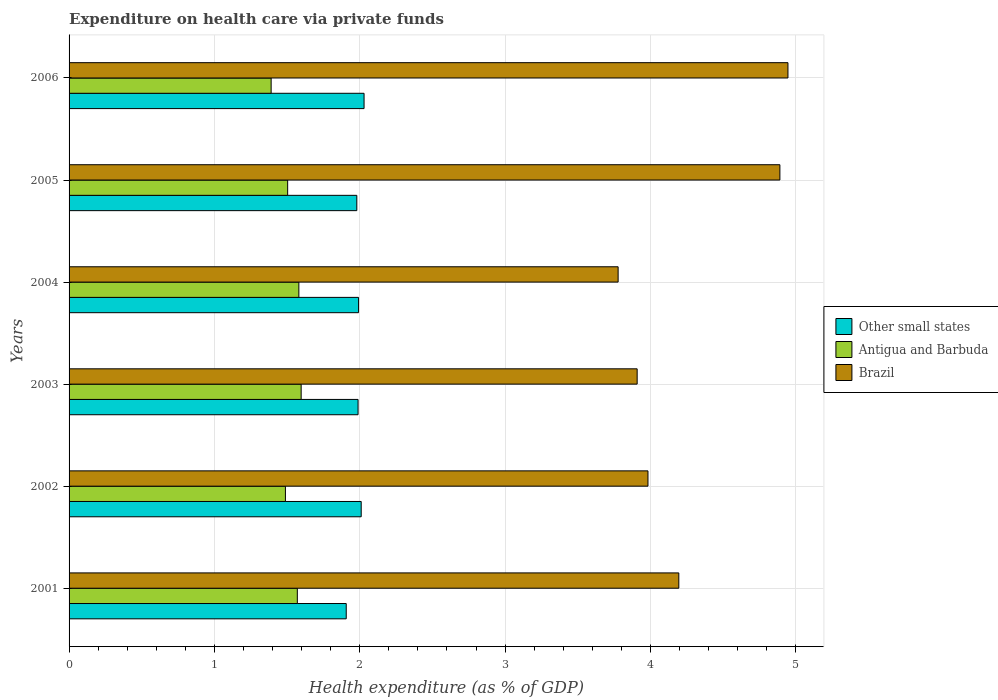How many different coloured bars are there?
Provide a succinct answer. 3. Are the number of bars per tick equal to the number of legend labels?
Keep it short and to the point. Yes. Are the number of bars on each tick of the Y-axis equal?
Offer a very short reply. Yes. How many bars are there on the 1st tick from the top?
Offer a terse response. 3. In how many cases, is the number of bars for a given year not equal to the number of legend labels?
Ensure brevity in your answer.  0. What is the expenditure made on health care in Brazil in 2003?
Ensure brevity in your answer.  3.91. Across all years, what is the maximum expenditure made on health care in Antigua and Barbuda?
Keep it short and to the point. 1.6. Across all years, what is the minimum expenditure made on health care in Antigua and Barbuda?
Ensure brevity in your answer.  1.39. What is the total expenditure made on health care in Antigua and Barbuda in the graph?
Your response must be concise. 9.13. What is the difference between the expenditure made on health care in Antigua and Barbuda in 2002 and that in 2005?
Give a very brief answer. -0.02. What is the difference between the expenditure made on health care in Other small states in 2004 and the expenditure made on health care in Antigua and Barbuda in 2003?
Give a very brief answer. 0.4. What is the average expenditure made on health care in Antigua and Barbuda per year?
Offer a very short reply. 1.52. In the year 2002, what is the difference between the expenditure made on health care in Antigua and Barbuda and expenditure made on health care in Brazil?
Your response must be concise. -2.49. What is the ratio of the expenditure made on health care in Other small states in 2001 to that in 2005?
Ensure brevity in your answer.  0.96. Is the expenditure made on health care in Brazil in 2003 less than that in 2005?
Your response must be concise. Yes. Is the difference between the expenditure made on health care in Antigua and Barbuda in 2003 and 2004 greater than the difference between the expenditure made on health care in Brazil in 2003 and 2004?
Keep it short and to the point. No. What is the difference between the highest and the second highest expenditure made on health care in Brazil?
Provide a succinct answer. 0.06. What is the difference between the highest and the lowest expenditure made on health care in Other small states?
Ensure brevity in your answer.  0.12. In how many years, is the expenditure made on health care in Brazil greater than the average expenditure made on health care in Brazil taken over all years?
Make the answer very short. 2. What does the 2nd bar from the top in 2005 represents?
Give a very brief answer. Antigua and Barbuda. How many bars are there?
Your response must be concise. 18. How many years are there in the graph?
Give a very brief answer. 6. Are the values on the major ticks of X-axis written in scientific E-notation?
Ensure brevity in your answer.  No. Does the graph contain any zero values?
Make the answer very short. No. Does the graph contain grids?
Ensure brevity in your answer.  Yes. How many legend labels are there?
Your response must be concise. 3. How are the legend labels stacked?
Offer a terse response. Vertical. What is the title of the graph?
Offer a very short reply. Expenditure on health care via private funds. Does "Sri Lanka" appear as one of the legend labels in the graph?
Your answer should be very brief. No. What is the label or title of the X-axis?
Provide a succinct answer. Health expenditure (as % of GDP). What is the Health expenditure (as % of GDP) of Other small states in 2001?
Provide a short and direct response. 1.91. What is the Health expenditure (as % of GDP) of Antigua and Barbuda in 2001?
Provide a short and direct response. 1.57. What is the Health expenditure (as % of GDP) in Brazil in 2001?
Offer a very short reply. 4.19. What is the Health expenditure (as % of GDP) of Other small states in 2002?
Your response must be concise. 2.01. What is the Health expenditure (as % of GDP) of Antigua and Barbuda in 2002?
Provide a succinct answer. 1.49. What is the Health expenditure (as % of GDP) of Brazil in 2002?
Your response must be concise. 3.98. What is the Health expenditure (as % of GDP) of Other small states in 2003?
Provide a short and direct response. 1.99. What is the Health expenditure (as % of GDP) in Antigua and Barbuda in 2003?
Your answer should be compact. 1.6. What is the Health expenditure (as % of GDP) of Brazil in 2003?
Give a very brief answer. 3.91. What is the Health expenditure (as % of GDP) of Other small states in 2004?
Offer a very short reply. 1.99. What is the Health expenditure (as % of GDP) of Antigua and Barbuda in 2004?
Offer a terse response. 1.58. What is the Health expenditure (as % of GDP) of Brazil in 2004?
Give a very brief answer. 3.78. What is the Health expenditure (as % of GDP) of Other small states in 2005?
Offer a very short reply. 1.98. What is the Health expenditure (as % of GDP) of Antigua and Barbuda in 2005?
Offer a terse response. 1.5. What is the Health expenditure (as % of GDP) of Brazil in 2005?
Your answer should be very brief. 4.89. What is the Health expenditure (as % of GDP) of Other small states in 2006?
Offer a terse response. 2.03. What is the Health expenditure (as % of GDP) of Antigua and Barbuda in 2006?
Make the answer very short. 1.39. What is the Health expenditure (as % of GDP) in Brazil in 2006?
Give a very brief answer. 4.95. Across all years, what is the maximum Health expenditure (as % of GDP) in Other small states?
Offer a terse response. 2.03. Across all years, what is the maximum Health expenditure (as % of GDP) of Antigua and Barbuda?
Offer a terse response. 1.6. Across all years, what is the maximum Health expenditure (as % of GDP) of Brazil?
Offer a terse response. 4.95. Across all years, what is the minimum Health expenditure (as % of GDP) in Other small states?
Your answer should be compact. 1.91. Across all years, what is the minimum Health expenditure (as % of GDP) of Antigua and Barbuda?
Your response must be concise. 1.39. Across all years, what is the minimum Health expenditure (as % of GDP) of Brazil?
Provide a succinct answer. 3.78. What is the total Health expenditure (as % of GDP) in Other small states in the graph?
Offer a terse response. 11.91. What is the total Health expenditure (as % of GDP) in Antigua and Barbuda in the graph?
Provide a succinct answer. 9.13. What is the total Health expenditure (as % of GDP) of Brazil in the graph?
Ensure brevity in your answer.  25.7. What is the difference between the Health expenditure (as % of GDP) of Other small states in 2001 and that in 2002?
Give a very brief answer. -0.1. What is the difference between the Health expenditure (as % of GDP) in Antigua and Barbuda in 2001 and that in 2002?
Offer a very short reply. 0.08. What is the difference between the Health expenditure (as % of GDP) of Brazil in 2001 and that in 2002?
Your answer should be compact. 0.21. What is the difference between the Health expenditure (as % of GDP) of Other small states in 2001 and that in 2003?
Your answer should be compact. -0.08. What is the difference between the Health expenditure (as % of GDP) in Antigua and Barbuda in 2001 and that in 2003?
Offer a terse response. -0.03. What is the difference between the Health expenditure (as % of GDP) of Brazil in 2001 and that in 2003?
Keep it short and to the point. 0.29. What is the difference between the Health expenditure (as % of GDP) in Other small states in 2001 and that in 2004?
Keep it short and to the point. -0.08. What is the difference between the Health expenditure (as % of GDP) in Antigua and Barbuda in 2001 and that in 2004?
Offer a terse response. -0.01. What is the difference between the Health expenditure (as % of GDP) of Brazil in 2001 and that in 2004?
Provide a short and direct response. 0.42. What is the difference between the Health expenditure (as % of GDP) of Other small states in 2001 and that in 2005?
Your answer should be very brief. -0.07. What is the difference between the Health expenditure (as % of GDP) of Antigua and Barbuda in 2001 and that in 2005?
Give a very brief answer. 0.07. What is the difference between the Health expenditure (as % of GDP) of Brazil in 2001 and that in 2005?
Provide a succinct answer. -0.7. What is the difference between the Health expenditure (as % of GDP) of Other small states in 2001 and that in 2006?
Your answer should be compact. -0.12. What is the difference between the Health expenditure (as % of GDP) in Antigua and Barbuda in 2001 and that in 2006?
Make the answer very short. 0.18. What is the difference between the Health expenditure (as % of GDP) of Brazil in 2001 and that in 2006?
Provide a short and direct response. -0.75. What is the difference between the Health expenditure (as % of GDP) in Other small states in 2002 and that in 2003?
Give a very brief answer. 0.02. What is the difference between the Health expenditure (as % of GDP) of Antigua and Barbuda in 2002 and that in 2003?
Your answer should be very brief. -0.11. What is the difference between the Health expenditure (as % of GDP) in Brazil in 2002 and that in 2003?
Provide a short and direct response. 0.07. What is the difference between the Health expenditure (as % of GDP) in Other small states in 2002 and that in 2004?
Give a very brief answer. 0.02. What is the difference between the Health expenditure (as % of GDP) in Antigua and Barbuda in 2002 and that in 2004?
Keep it short and to the point. -0.09. What is the difference between the Health expenditure (as % of GDP) in Brazil in 2002 and that in 2004?
Provide a succinct answer. 0.21. What is the difference between the Health expenditure (as % of GDP) in Other small states in 2002 and that in 2005?
Your answer should be very brief. 0.03. What is the difference between the Health expenditure (as % of GDP) of Antigua and Barbuda in 2002 and that in 2005?
Give a very brief answer. -0.02. What is the difference between the Health expenditure (as % of GDP) of Brazil in 2002 and that in 2005?
Your answer should be very brief. -0.91. What is the difference between the Health expenditure (as % of GDP) in Other small states in 2002 and that in 2006?
Make the answer very short. -0.02. What is the difference between the Health expenditure (as % of GDP) in Antigua and Barbuda in 2002 and that in 2006?
Offer a very short reply. 0.1. What is the difference between the Health expenditure (as % of GDP) of Brazil in 2002 and that in 2006?
Make the answer very short. -0.96. What is the difference between the Health expenditure (as % of GDP) of Other small states in 2003 and that in 2004?
Keep it short and to the point. -0. What is the difference between the Health expenditure (as % of GDP) of Antigua and Barbuda in 2003 and that in 2004?
Offer a very short reply. 0.02. What is the difference between the Health expenditure (as % of GDP) in Brazil in 2003 and that in 2004?
Provide a succinct answer. 0.13. What is the difference between the Health expenditure (as % of GDP) in Other small states in 2003 and that in 2005?
Keep it short and to the point. 0.01. What is the difference between the Health expenditure (as % of GDP) in Antigua and Barbuda in 2003 and that in 2005?
Give a very brief answer. 0.09. What is the difference between the Health expenditure (as % of GDP) of Brazil in 2003 and that in 2005?
Give a very brief answer. -0.98. What is the difference between the Health expenditure (as % of GDP) in Other small states in 2003 and that in 2006?
Offer a very short reply. -0.04. What is the difference between the Health expenditure (as % of GDP) in Antigua and Barbuda in 2003 and that in 2006?
Your answer should be very brief. 0.21. What is the difference between the Health expenditure (as % of GDP) in Brazil in 2003 and that in 2006?
Your response must be concise. -1.04. What is the difference between the Health expenditure (as % of GDP) in Other small states in 2004 and that in 2005?
Your answer should be compact. 0.01. What is the difference between the Health expenditure (as % of GDP) of Antigua and Barbuda in 2004 and that in 2005?
Keep it short and to the point. 0.08. What is the difference between the Health expenditure (as % of GDP) in Brazil in 2004 and that in 2005?
Offer a terse response. -1.11. What is the difference between the Health expenditure (as % of GDP) in Other small states in 2004 and that in 2006?
Provide a short and direct response. -0.04. What is the difference between the Health expenditure (as % of GDP) in Antigua and Barbuda in 2004 and that in 2006?
Offer a terse response. 0.19. What is the difference between the Health expenditure (as % of GDP) in Brazil in 2004 and that in 2006?
Give a very brief answer. -1.17. What is the difference between the Health expenditure (as % of GDP) of Other small states in 2005 and that in 2006?
Your answer should be compact. -0.05. What is the difference between the Health expenditure (as % of GDP) in Antigua and Barbuda in 2005 and that in 2006?
Offer a terse response. 0.11. What is the difference between the Health expenditure (as % of GDP) of Brazil in 2005 and that in 2006?
Provide a short and direct response. -0.06. What is the difference between the Health expenditure (as % of GDP) of Other small states in 2001 and the Health expenditure (as % of GDP) of Antigua and Barbuda in 2002?
Your response must be concise. 0.42. What is the difference between the Health expenditure (as % of GDP) in Other small states in 2001 and the Health expenditure (as % of GDP) in Brazil in 2002?
Make the answer very short. -2.08. What is the difference between the Health expenditure (as % of GDP) of Antigua and Barbuda in 2001 and the Health expenditure (as % of GDP) of Brazil in 2002?
Ensure brevity in your answer.  -2.41. What is the difference between the Health expenditure (as % of GDP) in Other small states in 2001 and the Health expenditure (as % of GDP) in Antigua and Barbuda in 2003?
Keep it short and to the point. 0.31. What is the difference between the Health expenditure (as % of GDP) of Other small states in 2001 and the Health expenditure (as % of GDP) of Brazil in 2003?
Offer a very short reply. -2. What is the difference between the Health expenditure (as % of GDP) in Antigua and Barbuda in 2001 and the Health expenditure (as % of GDP) in Brazil in 2003?
Your answer should be very brief. -2.34. What is the difference between the Health expenditure (as % of GDP) in Other small states in 2001 and the Health expenditure (as % of GDP) in Antigua and Barbuda in 2004?
Keep it short and to the point. 0.33. What is the difference between the Health expenditure (as % of GDP) in Other small states in 2001 and the Health expenditure (as % of GDP) in Brazil in 2004?
Your response must be concise. -1.87. What is the difference between the Health expenditure (as % of GDP) in Antigua and Barbuda in 2001 and the Health expenditure (as % of GDP) in Brazil in 2004?
Provide a succinct answer. -2.21. What is the difference between the Health expenditure (as % of GDP) of Other small states in 2001 and the Health expenditure (as % of GDP) of Antigua and Barbuda in 2005?
Make the answer very short. 0.4. What is the difference between the Health expenditure (as % of GDP) of Other small states in 2001 and the Health expenditure (as % of GDP) of Brazil in 2005?
Your answer should be compact. -2.98. What is the difference between the Health expenditure (as % of GDP) in Antigua and Barbuda in 2001 and the Health expenditure (as % of GDP) in Brazil in 2005?
Your response must be concise. -3.32. What is the difference between the Health expenditure (as % of GDP) of Other small states in 2001 and the Health expenditure (as % of GDP) of Antigua and Barbuda in 2006?
Provide a short and direct response. 0.52. What is the difference between the Health expenditure (as % of GDP) of Other small states in 2001 and the Health expenditure (as % of GDP) of Brazil in 2006?
Ensure brevity in your answer.  -3.04. What is the difference between the Health expenditure (as % of GDP) of Antigua and Barbuda in 2001 and the Health expenditure (as % of GDP) of Brazil in 2006?
Provide a short and direct response. -3.38. What is the difference between the Health expenditure (as % of GDP) of Other small states in 2002 and the Health expenditure (as % of GDP) of Antigua and Barbuda in 2003?
Offer a terse response. 0.41. What is the difference between the Health expenditure (as % of GDP) in Other small states in 2002 and the Health expenditure (as % of GDP) in Brazil in 2003?
Your answer should be compact. -1.9. What is the difference between the Health expenditure (as % of GDP) of Antigua and Barbuda in 2002 and the Health expenditure (as % of GDP) of Brazil in 2003?
Ensure brevity in your answer.  -2.42. What is the difference between the Health expenditure (as % of GDP) of Other small states in 2002 and the Health expenditure (as % of GDP) of Antigua and Barbuda in 2004?
Offer a terse response. 0.43. What is the difference between the Health expenditure (as % of GDP) in Other small states in 2002 and the Health expenditure (as % of GDP) in Brazil in 2004?
Give a very brief answer. -1.77. What is the difference between the Health expenditure (as % of GDP) in Antigua and Barbuda in 2002 and the Health expenditure (as % of GDP) in Brazil in 2004?
Your answer should be very brief. -2.29. What is the difference between the Health expenditure (as % of GDP) in Other small states in 2002 and the Health expenditure (as % of GDP) in Antigua and Barbuda in 2005?
Offer a terse response. 0.51. What is the difference between the Health expenditure (as % of GDP) in Other small states in 2002 and the Health expenditure (as % of GDP) in Brazil in 2005?
Your answer should be very brief. -2.88. What is the difference between the Health expenditure (as % of GDP) of Antigua and Barbuda in 2002 and the Health expenditure (as % of GDP) of Brazil in 2005?
Offer a very short reply. -3.4. What is the difference between the Health expenditure (as % of GDP) of Other small states in 2002 and the Health expenditure (as % of GDP) of Antigua and Barbuda in 2006?
Give a very brief answer. 0.62. What is the difference between the Health expenditure (as % of GDP) in Other small states in 2002 and the Health expenditure (as % of GDP) in Brazil in 2006?
Your answer should be very brief. -2.94. What is the difference between the Health expenditure (as % of GDP) in Antigua and Barbuda in 2002 and the Health expenditure (as % of GDP) in Brazil in 2006?
Make the answer very short. -3.46. What is the difference between the Health expenditure (as % of GDP) in Other small states in 2003 and the Health expenditure (as % of GDP) in Antigua and Barbuda in 2004?
Ensure brevity in your answer.  0.41. What is the difference between the Health expenditure (as % of GDP) in Other small states in 2003 and the Health expenditure (as % of GDP) in Brazil in 2004?
Provide a short and direct response. -1.79. What is the difference between the Health expenditure (as % of GDP) in Antigua and Barbuda in 2003 and the Health expenditure (as % of GDP) in Brazil in 2004?
Provide a succinct answer. -2.18. What is the difference between the Health expenditure (as % of GDP) of Other small states in 2003 and the Health expenditure (as % of GDP) of Antigua and Barbuda in 2005?
Offer a terse response. 0.48. What is the difference between the Health expenditure (as % of GDP) in Other small states in 2003 and the Health expenditure (as % of GDP) in Brazil in 2005?
Your response must be concise. -2.9. What is the difference between the Health expenditure (as % of GDP) of Antigua and Barbuda in 2003 and the Health expenditure (as % of GDP) of Brazil in 2005?
Your response must be concise. -3.29. What is the difference between the Health expenditure (as % of GDP) in Other small states in 2003 and the Health expenditure (as % of GDP) in Antigua and Barbuda in 2006?
Offer a very short reply. 0.6. What is the difference between the Health expenditure (as % of GDP) in Other small states in 2003 and the Health expenditure (as % of GDP) in Brazil in 2006?
Provide a short and direct response. -2.96. What is the difference between the Health expenditure (as % of GDP) in Antigua and Barbuda in 2003 and the Health expenditure (as % of GDP) in Brazil in 2006?
Your answer should be very brief. -3.35. What is the difference between the Health expenditure (as % of GDP) in Other small states in 2004 and the Health expenditure (as % of GDP) in Antigua and Barbuda in 2005?
Make the answer very short. 0.49. What is the difference between the Health expenditure (as % of GDP) in Other small states in 2004 and the Health expenditure (as % of GDP) in Brazil in 2005?
Ensure brevity in your answer.  -2.9. What is the difference between the Health expenditure (as % of GDP) of Antigua and Barbuda in 2004 and the Health expenditure (as % of GDP) of Brazil in 2005?
Provide a short and direct response. -3.31. What is the difference between the Health expenditure (as % of GDP) in Other small states in 2004 and the Health expenditure (as % of GDP) in Antigua and Barbuda in 2006?
Ensure brevity in your answer.  0.6. What is the difference between the Health expenditure (as % of GDP) of Other small states in 2004 and the Health expenditure (as % of GDP) of Brazil in 2006?
Your answer should be very brief. -2.95. What is the difference between the Health expenditure (as % of GDP) in Antigua and Barbuda in 2004 and the Health expenditure (as % of GDP) in Brazil in 2006?
Offer a terse response. -3.36. What is the difference between the Health expenditure (as % of GDP) in Other small states in 2005 and the Health expenditure (as % of GDP) in Antigua and Barbuda in 2006?
Provide a succinct answer. 0.59. What is the difference between the Health expenditure (as % of GDP) in Other small states in 2005 and the Health expenditure (as % of GDP) in Brazil in 2006?
Provide a short and direct response. -2.97. What is the difference between the Health expenditure (as % of GDP) of Antigua and Barbuda in 2005 and the Health expenditure (as % of GDP) of Brazil in 2006?
Provide a short and direct response. -3.44. What is the average Health expenditure (as % of GDP) in Other small states per year?
Offer a terse response. 1.98. What is the average Health expenditure (as % of GDP) in Antigua and Barbuda per year?
Ensure brevity in your answer.  1.52. What is the average Health expenditure (as % of GDP) of Brazil per year?
Keep it short and to the point. 4.28. In the year 2001, what is the difference between the Health expenditure (as % of GDP) in Other small states and Health expenditure (as % of GDP) in Antigua and Barbuda?
Your response must be concise. 0.34. In the year 2001, what is the difference between the Health expenditure (as % of GDP) in Other small states and Health expenditure (as % of GDP) in Brazil?
Offer a very short reply. -2.29. In the year 2001, what is the difference between the Health expenditure (as % of GDP) in Antigua and Barbuda and Health expenditure (as % of GDP) in Brazil?
Provide a short and direct response. -2.62. In the year 2002, what is the difference between the Health expenditure (as % of GDP) of Other small states and Health expenditure (as % of GDP) of Antigua and Barbuda?
Your response must be concise. 0.52. In the year 2002, what is the difference between the Health expenditure (as % of GDP) in Other small states and Health expenditure (as % of GDP) in Brazil?
Ensure brevity in your answer.  -1.97. In the year 2002, what is the difference between the Health expenditure (as % of GDP) in Antigua and Barbuda and Health expenditure (as % of GDP) in Brazil?
Offer a very short reply. -2.49. In the year 2003, what is the difference between the Health expenditure (as % of GDP) of Other small states and Health expenditure (as % of GDP) of Antigua and Barbuda?
Offer a very short reply. 0.39. In the year 2003, what is the difference between the Health expenditure (as % of GDP) of Other small states and Health expenditure (as % of GDP) of Brazil?
Your answer should be compact. -1.92. In the year 2003, what is the difference between the Health expenditure (as % of GDP) of Antigua and Barbuda and Health expenditure (as % of GDP) of Brazil?
Your answer should be very brief. -2.31. In the year 2004, what is the difference between the Health expenditure (as % of GDP) in Other small states and Health expenditure (as % of GDP) in Antigua and Barbuda?
Provide a succinct answer. 0.41. In the year 2004, what is the difference between the Health expenditure (as % of GDP) in Other small states and Health expenditure (as % of GDP) in Brazil?
Offer a very short reply. -1.79. In the year 2004, what is the difference between the Health expenditure (as % of GDP) in Antigua and Barbuda and Health expenditure (as % of GDP) in Brazil?
Keep it short and to the point. -2.2. In the year 2005, what is the difference between the Health expenditure (as % of GDP) of Other small states and Health expenditure (as % of GDP) of Antigua and Barbuda?
Your answer should be compact. 0.48. In the year 2005, what is the difference between the Health expenditure (as % of GDP) of Other small states and Health expenditure (as % of GDP) of Brazil?
Your answer should be compact. -2.91. In the year 2005, what is the difference between the Health expenditure (as % of GDP) in Antigua and Barbuda and Health expenditure (as % of GDP) in Brazil?
Provide a short and direct response. -3.39. In the year 2006, what is the difference between the Health expenditure (as % of GDP) of Other small states and Health expenditure (as % of GDP) of Antigua and Barbuda?
Provide a short and direct response. 0.64. In the year 2006, what is the difference between the Health expenditure (as % of GDP) in Other small states and Health expenditure (as % of GDP) in Brazil?
Keep it short and to the point. -2.92. In the year 2006, what is the difference between the Health expenditure (as % of GDP) in Antigua and Barbuda and Health expenditure (as % of GDP) in Brazil?
Offer a very short reply. -3.56. What is the ratio of the Health expenditure (as % of GDP) of Other small states in 2001 to that in 2002?
Give a very brief answer. 0.95. What is the ratio of the Health expenditure (as % of GDP) in Antigua and Barbuda in 2001 to that in 2002?
Your response must be concise. 1.06. What is the ratio of the Health expenditure (as % of GDP) in Brazil in 2001 to that in 2002?
Offer a very short reply. 1.05. What is the ratio of the Health expenditure (as % of GDP) in Antigua and Barbuda in 2001 to that in 2003?
Provide a succinct answer. 0.98. What is the ratio of the Health expenditure (as % of GDP) in Brazil in 2001 to that in 2003?
Ensure brevity in your answer.  1.07. What is the ratio of the Health expenditure (as % of GDP) in Other small states in 2001 to that in 2004?
Your response must be concise. 0.96. What is the ratio of the Health expenditure (as % of GDP) of Antigua and Barbuda in 2001 to that in 2004?
Offer a very short reply. 0.99. What is the ratio of the Health expenditure (as % of GDP) of Brazil in 2001 to that in 2004?
Provide a short and direct response. 1.11. What is the ratio of the Health expenditure (as % of GDP) in Other small states in 2001 to that in 2005?
Offer a terse response. 0.96. What is the ratio of the Health expenditure (as % of GDP) in Antigua and Barbuda in 2001 to that in 2005?
Provide a short and direct response. 1.04. What is the ratio of the Health expenditure (as % of GDP) of Brazil in 2001 to that in 2005?
Your answer should be compact. 0.86. What is the ratio of the Health expenditure (as % of GDP) in Other small states in 2001 to that in 2006?
Make the answer very short. 0.94. What is the ratio of the Health expenditure (as % of GDP) in Antigua and Barbuda in 2001 to that in 2006?
Provide a succinct answer. 1.13. What is the ratio of the Health expenditure (as % of GDP) in Brazil in 2001 to that in 2006?
Your answer should be very brief. 0.85. What is the ratio of the Health expenditure (as % of GDP) of Other small states in 2002 to that in 2003?
Keep it short and to the point. 1.01. What is the ratio of the Health expenditure (as % of GDP) in Antigua and Barbuda in 2002 to that in 2003?
Provide a succinct answer. 0.93. What is the ratio of the Health expenditure (as % of GDP) of Other small states in 2002 to that in 2004?
Keep it short and to the point. 1.01. What is the ratio of the Health expenditure (as % of GDP) in Antigua and Barbuda in 2002 to that in 2004?
Keep it short and to the point. 0.94. What is the ratio of the Health expenditure (as % of GDP) of Brazil in 2002 to that in 2004?
Your answer should be very brief. 1.05. What is the ratio of the Health expenditure (as % of GDP) of Other small states in 2002 to that in 2005?
Provide a short and direct response. 1.02. What is the ratio of the Health expenditure (as % of GDP) in Antigua and Barbuda in 2002 to that in 2005?
Give a very brief answer. 0.99. What is the ratio of the Health expenditure (as % of GDP) of Brazil in 2002 to that in 2005?
Ensure brevity in your answer.  0.81. What is the ratio of the Health expenditure (as % of GDP) of Other small states in 2002 to that in 2006?
Your response must be concise. 0.99. What is the ratio of the Health expenditure (as % of GDP) in Antigua and Barbuda in 2002 to that in 2006?
Offer a terse response. 1.07. What is the ratio of the Health expenditure (as % of GDP) in Brazil in 2002 to that in 2006?
Provide a succinct answer. 0.81. What is the ratio of the Health expenditure (as % of GDP) in Antigua and Barbuda in 2003 to that in 2004?
Offer a very short reply. 1.01. What is the ratio of the Health expenditure (as % of GDP) in Brazil in 2003 to that in 2004?
Your response must be concise. 1.03. What is the ratio of the Health expenditure (as % of GDP) in Other small states in 2003 to that in 2005?
Your answer should be very brief. 1. What is the ratio of the Health expenditure (as % of GDP) in Antigua and Barbuda in 2003 to that in 2005?
Provide a short and direct response. 1.06. What is the ratio of the Health expenditure (as % of GDP) in Brazil in 2003 to that in 2005?
Ensure brevity in your answer.  0.8. What is the ratio of the Health expenditure (as % of GDP) of Other small states in 2003 to that in 2006?
Provide a short and direct response. 0.98. What is the ratio of the Health expenditure (as % of GDP) in Antigua and Barbuda in 2003 to that in 2006?
Your response must be concise. 1.15. What is the ratio of the Health expenditure (as % of GDP) in Brazil in 2003 to that in 2006?
Offer a terse response. 0.79. What is the ratio of the Health expenditure (as % of GDP) in Other small states in 2004 to that in 2005?
Keep it short and to the point. 1.01. What is the ratio of the Health expenditure (as % of GDP) in Antigua and Barbuda in 2004 to that in 2005?
Make the answer very short. 1.05. What is the ratio of the Health expenditure (as % of GDP) in Brazil in 2004 to that in 2005?
Make the answer very short. 0.77. What is the ratio of the Health expenditure (as % of GDP) of Other small states in 2004 to that in 2006?
Give a very brief answer. 0.98. What is the ratio of the Health expenditure (as % of GDP) in Antigua and Barbuda in 2004 to that in 2006?
Give a very brief answer. 1.14. What is the ratio of the Health expenditure (as % of GDP) of Brazil in 2004 to that in 2006?
Ensure brevity in your answer.  0.76. What is the ratio of the Health expenditure (as % of GDP) of Other small states in 2005 to that in 2006?
Your answer should be compact. 0.98. What is the ratio of the Health expenditure (as % of GDP) of Antigua and Barbuda in 2005 to that in 2006?
Make the answer very short. 1.08. What is the difference between the highest and the second highest Health expenditure (as % of GDP) of Other small states?
Provide a short and direct response. 0.02. What is the difference between the highest and the second highest Health expenditure (as % of GDP) in Antigua and Barbuda?
Provide a succinct answer. 0.02. What is the difference between the highest and the second highest Health expenditure (as % of GDP) of Brazil?
Ensure brevity in your answer.  0.06. What is the difference between the highest and the lowest Health expenditure (as % of GDP) of Other small states?
Your response must be concise. 0.12. What is the difference between the highest and the lowest Health expenditure (as % of GDP) of Antigua and Barbuda?
Provide a short and direct response. 0.21. What is the difference between the highest and the lowest Health expenditure (as % of GDP) in Brazil?
Keep it short and to the point. 1.17. 